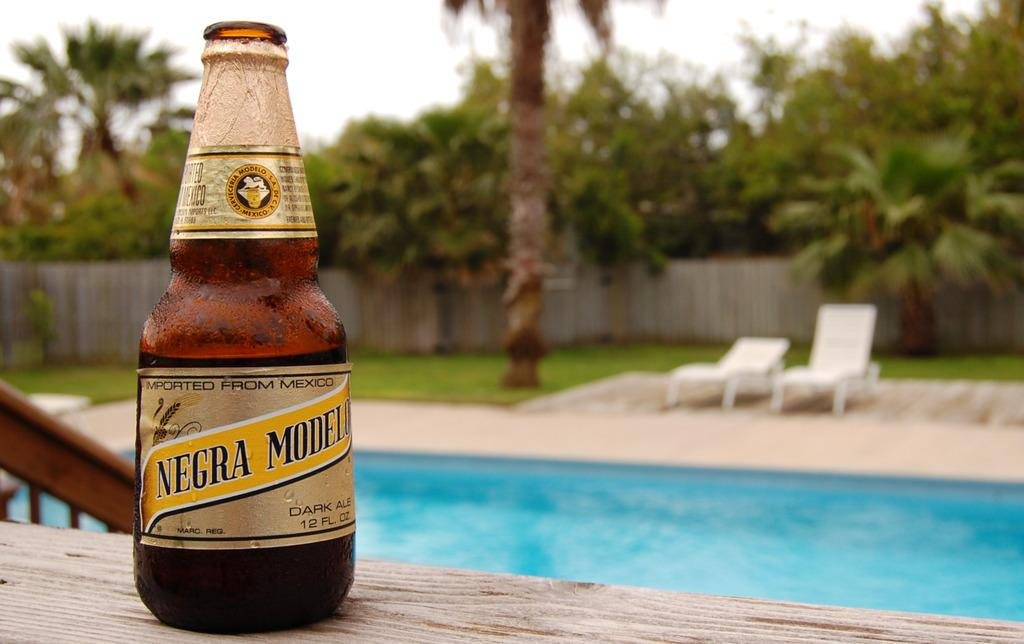Provide a one-sentence caption for the provided image. A bottle of beer that has been imported from Mexico. 